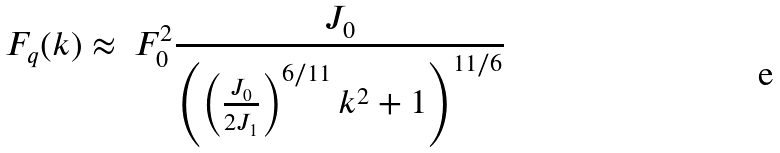Convert formula to latex. <formula><loc_0><loc_0><loc_500><loc_500>F _ { q } ( k ) \approx \ F _ { 0 } ^ { 2 } \frac { J _ { 0 } } { \left ( \left ( \frac { J _ { 0 } } { 2 J _ { 1 } } \right ) ^ { 6 / 1 1 } k ^ { 2 } + 1 \right ) ^ { 1 1 / 6 } }</formula> 